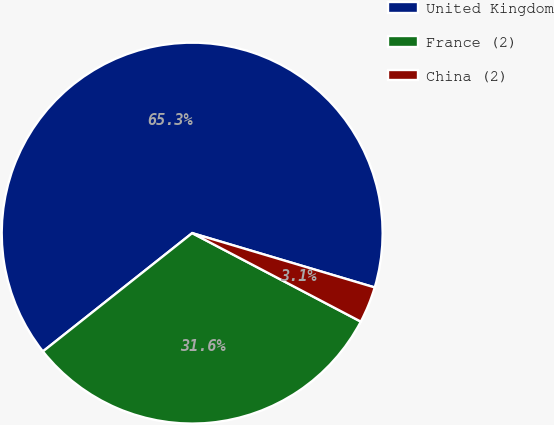Convert chart to OTSL. <chart><loc_0><loc_0><loc_500><loc_500><pie_chart><fcel>United Kingdom<fcel>France (2)<fcel>China (2)<nl><fcel>65.27%<fcel>31.64%<fcel>3.09%<nl></chart> 